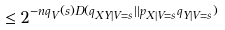<formula> <loc_0><loc_0><loc_500><loc_500>\leq 2 ^ { - n q _ { V } ( s ) D ( q _ { X Y | V = s } | | p _ { X | V = s } q _ { Y | V = s } ) }</formula> 